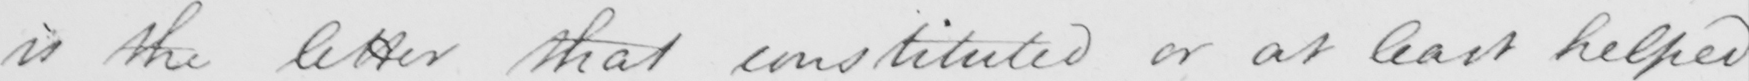Please provide the text content of this handwritten line. is the letter that constituted or at least helped 